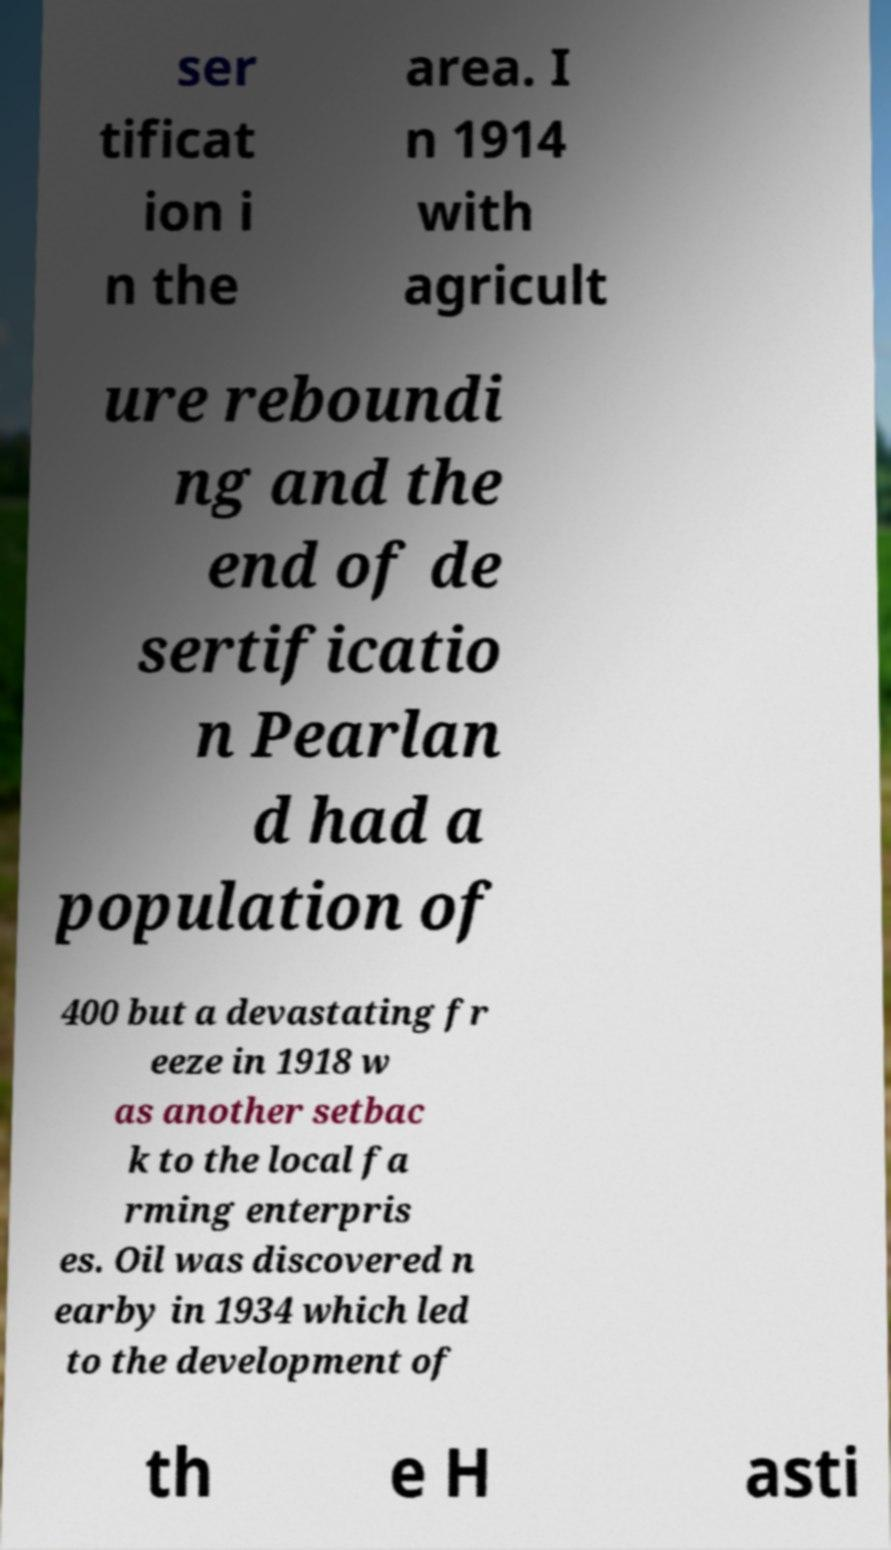For documentation purposes, I need the text within this image transcribed. Could you provide that? ser tificat ion i n the area. I n 1914 with agricult ure reboundi ng and the end of de sertificatio n Pearlan d had a population of 400 but a devastating fr eeze in 1918 w as another setbac k to the local fa rming enterpris es. Oil was discovered n earby in 1934 which led to the development of th e H asti 